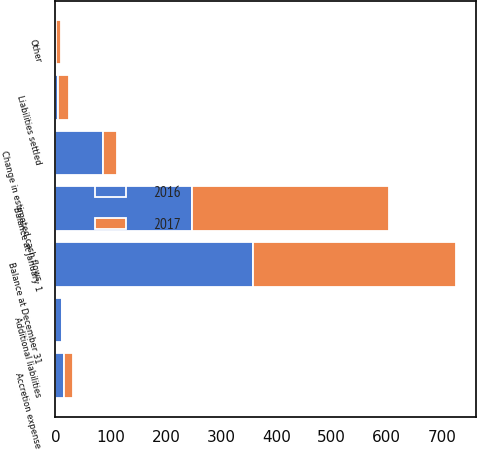<chart> <loc_0><loc_0><loc_500><loc_500><stacked_bar_chart><ecel><fcel>Balance at January 1<fcel>Additional liabilities<fcel>Liabilities settled<fcel>Accretion expense<fcel>Change in estimated cash flows<fcel>Other<fcel>Balance at December 31<nl><fcel>2017<fcel>357<fcel>1<fcel>21<fcel>16<fcel>25<fcel>10<fcel>368<nl><fcel>2016<fcel>247<fcel>12<fcel>4<fcel>15<fcel>86<fcel>1<fcel>357<nl></chart> 